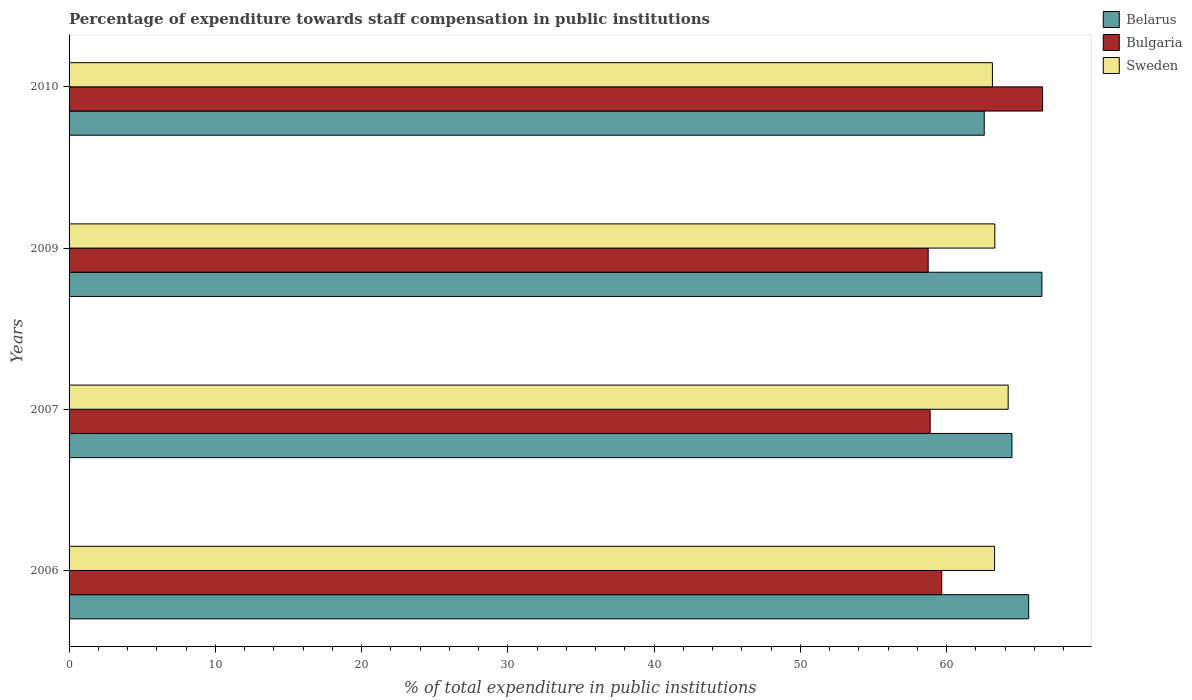How many groups of bars are there?
Your answer should be very brief. 4. Are the number of bars per tick equal to the number of legend labels?
Your answer should be very brief. Yes. Are the number of bars on each tick of the Y-axis equal?
Offer a terse response. Yes. How many bars are there on the 2nd tick from the top?
Give a very brief answer. 3. How many bars are there on the 2nd tick from the bottom?
Provide a short and direct response. 3. What is the label of the 2nd group of bars from the top?
Keep it short and to the point. 2009. What is the percentage of expenditure towards staff compensation in Bulgaria in 2006?
Offer a very short reply. 59.66. Across all years, what is the maximum percentage of expenditure towards staff compensation in Sweden?
Ensure brevity in your answer.  64.2. Across all years, what is the minimum percentage of expenditure towards staff compensation in Sweden?
Ensure brevity in your answer.  63.13. In which year was the percentage of expenditure towards staff compensation in Sweden minimum?
Provide a short and direct response. 2010. What is the total percentage of expenditure towards staff compensation in Sweden in the graph?
Offer a very short reply. 253.89. What is the difference between the percentage of expenditure towards staff compensation in Sweden in 2007 and that in 2009?
Offer a terse response. 0.91. What is the difference between the percentage of expenditure towards staff compensation in Sweden in 2006 and the percentage of expenditure towards staff compensation in Bulgaria in 2007?
Your answer should be very brief. 4.4. What is the average percentage of expenditure towards staff compensation in Bulgaria per year?
Ensure brevity in your answer.  60.95. In the year 2006, what is the difference between the percentage of expenditure towards staff compensation in Bulgaria and percentage of expenditure towards staff compensation in Belarus?
Your answer should be compact. -5.95. In how many years, is the percentage of expenditure towards staff compensation in Belarus greater than 46 %?
Provide a short and direct response. 4. What is the ratio of the percentage of expenditure towards staff compensation in Sweden in 2007 to that in 2010?
Offer a very short reply. 1.02. Is the percentage of expenditure towards staff compensation in Belarus in 2006 less than that in 2009?
Offer a terse response. Yes. Is the difference between the percentage of expenditure towards staff compensation in Bulgaria in 2006 and 2007 greater than the difference between the percentage of expenditure towards staff compensation in Belarus in 2006 and 2007?
Keep it short and to the point. No. What is the difference between the highest and the second highest percentage of expenditure towards staff compensation in Bulgaria?
Ensure brevity in your answer.  6.9. What is the difference between the highest and the lowest percentage of expenditure towards staff compensation in Bulgaria?
Give a very brief answer. 7.82. Is the sum of the percentage of expenditure towards staff compensation in Belarus in 2007 and 2009 greater than the maximum percentage of expenditure towards staff compensation in Bulgaria across all years?
Provide a succinct answer. Yes. What does the 3rd bar from the top in 2006 represents?
Your answer should be very brief. Belarus. What does the 1st bar from the bottom in 2006 represents?
Your answer should be very brief. Belarus. How many bars are there?
Give a very brief answer. 12. Are all the bars in the graph horizontal?
Provide a short and direct response. Yes. What is the difference between two consecutive major ticks on the X-axis?
Keep it short and to the point. 10. Does the graph contain grids?
Ensure brevity in your answer.  No. Where does the legend appear in the graph?
Keep it short and to the point. Top right. How are the legend labels stacked?
Provide a short and direct response. Vertical. What is the title of the graph?
Offer a very short reply. Percentage of expenditure towards staff compensation in public institutions. What is the label or title of the X-axis?
Make the answer very short. % of total expenditure in public institutions. What is the label or title of the Y-axis?
Keep it short and to the point. Years. What is the % of total expenditure in public institutions in Belarus in 2006?
Make the answer very short. 65.6. What is the % of total expenditure in public institutions in Bulgaria in 2006?
Offer a terse response. 59.66. What is the % of total expenditure in public institutions of Sweden in 2006?
Offer a very short reply. 63.27. What is the % of total expenditure in public institutions of Belarus in 2007?
Your answer should be compact. 64.46. What is the % of total expenditure in public institutions in Bulgaria in 2007?
Your answer should be very brief. 58.87. What is the % of total expenditure in public institutions in Sweden in 2007?
Your answer should be compact. 64.2. What is the % of total expenditure in public institutions in Belarus in 2009?
Give a very brief answer. 66.51. What is the % of total expenditure in public institutions in Bulgaria in 2009?
Your answer should be very brief. 58.73. What is the % of total expenditure in public institutions in Sweden in 2009?
Provide a succinct answer. 63.29. What is the % of total expenditure in public institutions of Belarus in 2010?
Your response must be concise. 62.57. What is the % of total expenditure in public institutions in Bulgaria in 2010?
Your response must be concise. 66.56. What is the % of total expenditure in public institutions in Sweden in 2010?
Ensure brevity in your answer.  63.13. Across all years, what is the maximum % of total expenditure in public institutions in Belarus?
Provide a succinct answer. 66.51. Across all years, what is the maximum % of total expenditure in public institutions of Bulgaria?
Provide a succinct answer. 66.56. Across all years, what is the maximum % of total expenditure in public institutions of Sweden?
Keep it short and to the point. 64.2. Across all years, what is the minimum % of total expenditure in public institutions of Belarus?
Offer a very short reply. 62.57. Across all years, what is the minimum % of total expenditure in public institutions in Bulgaria?
Your answer should be very brief. 58.73. Across all years, what is the minimum % of total expenditure in public institutions of Sweden?
Provide a succinct answer. 63.13. What is the total % of total expenditure in public institutions of Belarus in the graph?
Your response must be concise. 259.15. What is the total % of total expenditure in public institutions of Bulgaria in the graph?
Make the answer very short. 243.82. What is the total % of total expenditure in public institutions in Sweden in the graph?
Ensure brevity in your answer.  253.89. What is the difference between the % of total expenditure in public institutions in Belarus in 2006 and that in 2007?
Your response must be concise. 1.14. What is the difference between the % of total expenditure in public institutions in Bulgaria in 2006 and that in 2007?
Offer a terse response. 0.79. What is the difference between the % of total expenditure in public institutions in Sweden in 2006 and that in 2007?
Make the answer very short. -0.93. What is the difference between the % of total expenditure in public institutions in Belarus in 2006 and that in 2009?
Ensure brevity in your answer.  -0.91. What is the difference between the % of total expenditure in public institutions in Bulgaria in 2006 and that in 2009?
Offer a very short reply. 0.93. What is the difference between the % of total expenditure in public institutions of Sweden in 2006 and that in 2009?
Make the answer very short. -0.02. What is the difference between the % of total expenditure in public institutions in Belarus in 2006 and that in 2010?
Make the answer very short. 3.04. What is the difference between the % of total expenditure in public institutions of Bulgaria in 2006 and that in 2010?
Provide a short and direct response. -6.9. What is the difference between the % of total expenditure in public institutions of Sweden in 2006 and that in 2010?
Keep it short and to the point. 0.15. What is the difference between the % of total expenditure in public institutions in Belarus in 2007 and that in 2009?
Give a very brief answer. -2.05. What is the difference between the % of total expenditure in public institutions of Bulgaria in 2007 and that in 2009?
Provide a succinct answer. 0.14. What is the difference between the % of total expenditure in public institutions in Sweden in 2007 and that in 2009?
Offer a terse response. 0.91. What is the difference between the % of total expenditure in public institutions of Belarus in 2007 and that in 2010?
Provide a short and direct response. 1.89. What is the difference between the % of total expenditure in public institutions of Bulgaria in 2007 and that in 2010?
Your answer should be compact. -7.69. What is the difference between the % of total expenditure in public institutions in Sweden in 2007 and that in 2010?
Your answer should be compact. 1.08. What is the difference between the % of total expenditure in public institutions in Belarus in 2009 and that in 2010?
Provide a succinct answer. 3.94. What is the difference between the % of total expenditure in public institutions of Bulgaria in 2009 and that in 2010?
Your response must be concise. -7.82. What is the difference between the % of total expenditure in public institutions of Sweden in 2009 and that in 2010?
Offer a terse response. 0.17. What is the difference between the % of total expenditure in public institutions of Belarus in 2006 and the % of total expenditure in public institutions of Bulgaria in 2007?
Provide a succinct answer. 6.73. What is the difference between the % of total expenditure in public institutions in Belarus in 2006 and the % of total expenditure in public institutions in Sweden in 2007?
Provide a short and direct response. 1.4. What is the difference between the % of total expenditure in public institutions in Bulgaria in 2006 and the % of total expenditure in public institutions in Sweden in 2007?
Make the answer very short. -4.54. What is the difference between the % of total expenditure in public institutions in Belarus in 2006 and the % of total expenditure in public institutions in Bulgaria in 2009?
Your response must be concise. 6.87. What is the difference between the % of total expenditure in public institutions in Belarus in 2006 and the % of total expenditure in public institutions in Sweden in 2009?
Offer a very short reply. 2.31. What is the difference between the % of total expenditure in public institutions of Bulgaria in 2006 and the % of total expenditure in public institutions of Sweden in 2009?
Keep it short and to the point. -3.63. What is the difference between the % of total expenditure in public institutions of Belarus in 2006 and the % of total expenditure in public institutions of Bulgaria in 2010?
Your response must be concise. -0.95. What is the difference between the % of total expenditure in public institutions in Belarus in 2006 and the % of total expenditure in public institutions in Sweden in 2010?
Make the answer very short. 2.48. What is the difference between the % of total expenditure in public institutions in Bulgaria in 2006 and the % of total expenditure in public institutions in Sweden in 2010?
Your answer should be compact. -3.47. What is the difference between the % of total expenditure in public institutions in Belarus in 2007 and the % of total expenditure in public institutions in Bulgaria in 2009?
Your answer should be very brief. 5.73. What is the difference between the % of total expenditure in public institutions in Belarus in 2007 and the % of total expenditure in public institutions in Sweden in 2009?
Your answer should be compact. 1.17. What is the difference between the % of total expenditure in public institutions in Bulgaria in 2007 and the % of total expenditure in public institutions in Sweden in 2009?
Offer a very short reply. -4.42. What is the difference between the % of total expenditure in public institutions of Belarus in 2007 and the % of total expenditure in public institutions of Bulgaria in 2010?
Give a very brief answer. -2.09. What is the difference between the % of total expenditure in public institutions in Belarus in 2007 and the % of total expenditure in public institutions in Sweden in 2010?
Offer a very short reply. 1.34. What is the difference between the % of total expenditure in public institutions in Bulgaria in 2007 and the % of total expenditure in public institutions in Sweden in 2010?
Give a very brief answer. -4.26. What is the difference between the % of total expenditure in public institutions in Belarus in 2009 and the % of total expenditure in public institutions in Bulgaria in 2010?
Provide a succinct answer. -0.04. What is the difference between the % of total expenditure in public institutions of Belarus in 2009 and the % of total expenditure in public institutions of Sweden in 2010?
Offer a very short reply. 3.39. What is the difference between the % of total expenditure in public institutions of Bulgaria in 2009 and the % of total expenditure in public institutions of Sweden in 2010?
Offer a very short reply. -4.39. What is the average % of total expenditure in public institutions in Belarus per year?
Your response must be concise. 64.79. What is the average % of total expenditure in public institutions of Bulgaria per year?
Make the answer very short. 60.95. What is the average % of total expenditure in public institutions in Sweden per year?
Your response must be concise. 63.47. In the year 2006, what is the difference between the % of total expenditure in public institutions in Belarus and % of total expenditure in public institutions in Bulgaria?
Provide a short and direct response. 5.95. In the year 2006, what is the difference between the % of total expenditure in public institutions of Belarus and % of total expenditure in public institutions of Sweden?
Your answer should be very brief. 2.33. In the year 2006, what is the difference between the % of total expenditure in public institutions of Bulgaria and % of total expenditure in public institutions of Sweden?
Keep it short and to the point. -3.61. In the year 2007, what is the difference between the % of total expenditure in public institutions in Belarus and % of total expenditure in public institutions in Bulgaria?
Provide a short and direct response. 5.59. In the year 2007, what is the difference between the % of total expenditure in public institutions of Belarus and % of total expenditure in public institutions of Sweden?
Provide a short and direct response. 0.26. In the year 2007, what is the difference between the % of total expenditure in public institutions in Bulgaria and % of total expenditure in public institutions in Sweden?
Offer a very short reply. -5.33. In the year 2009, what is the difference between the % of total expenditure in public institutions in Belarus and % of total expenditure in public institutions in Bulgaria?
Keep it short and to the point. 7.78. In the year 2009, what is the difference between the % of total expenditure in public institutions in Belarus and % of total expenditure in public institutions in Sweden?
Make the answer very short. 3.22. In the year 2009, what is the difference between the % of total expenditure in public institutions of Bulgaria and % of total expenditure in public institutions of Sweden?
Offer a very short reply. -4.56. In the year 2010, what is the difference between the % of total expenditure in public institutions of Belarus and % of total expenditure in public institutions of Bulgaria?
Keep it short and to the point. -3.99. In the year 2010, what is the difference between the % of total expenditure in public institutions in Belarus and % of total expenditure in public institutions in Sweden?
Provide a succinct answer. -0.56. In the year 2010, what is the difference between the % of total expenditure in public institutions of Bulgaria and % of total expenditure in public institutions of Sweden?
Make the answer very short. 3.43. What is the ratio of the % of total expenditure in public institutions of Belarus in 2006 to that in 2007?
Offer a very short reply. 1.02. What is the ratio of the % of total expenditure in public institutions of Bulgaria in 2006 to that in 2007?
Give a very brief answer. 1.01. What is the ratio of the % of total expenditure in public institutions of Sweden in 2006 to that in 2007?
Provide a succinct answer. 0.99. What is the ratio of the % of total expenditure in public institutions in Belarus in 2006 to that in 2009?
Your answer should be compact. 0.99. What is the ratio of the % of total expenditure in public institutions in Bulgaria in 2006 to that in 2009?
Ensure brevity in your answer.  1.02. What is the ratio of the % of total expenditure in public institutions in Sweden in 2006 to that in 2009?
Your answer should be compact. 1. What is the ratio of the % of total expenditure in public institutions in Belarus in 2006 to that in 2010?
Give a very brief answer. 1.05. What is the ratio of the % of total expenditure in public institutions of Bulgaria in 2006 to that in 2010?
Give a very brief answer. 0.9. What is the ratio of the % of total expenditure in public institutions in Sweden in 2006 to that in 2010?
Your answer should be compact. 1. What is the ratio of the % of total expenditure in public institutions in Belarus in 2007 to that in 2009?
Your response must be concise. 0.97. What is the ratio of the % of total expenditure in public institutions of Bulgaria in 2007 to that in 2009?
Offer a terse response. 1. What is the ratio of the % of total expenditure in public institutions of Sweden in 2007 to that in 2009?
Provide a succinct answer. 1.01. What is the ratio of the % of total expenditure in public institutions of Belarus in 2007 to that in 2010?
Provide a short and direct response. 1.03. What is the ratio of the % of total expenditure in public institutions in Bulgaria in 2007 to that in 2010?
Ensure brevity in your answer.  0.88. What is the ratio of the % of total expenditure in public institutions in Sweden in 2007 to that in 2010?
Ensure brevity in your answer.  1.02. What is the ratio of the % of total expenditure in public institutions in Belarus in 2009 to that in 2010?
Your response must be concise. 1.06. What is the ratio of the % of total expenditure in public institutions in Bulgaria in 2009 to that in 2010?
Offer a very short reply. 0.88. What is the ratio of the % of total expenditure in public institutions in Sweden in 2009 to that in 2010?
Give a very brief answer. 1. What is the difference between the highest and the second highest % of total expenditure in public institutions in Belarus?
Make the answer very short. 0.91. What is the difference between the highest and the second highest % of total expenditure in public institutions of Bulgaria?
Your response must be concise. 6.9. What is the difference between the highest and the second highest % of total expenditure in public institutions in Sweden?
Offer a terse response. 0.91. What is the difference between the highest and the lowest % of total expenditure in public institutions of Belarus?
Your response must be concise. 3.94. What is the difference between the highest and the lowest % of total expenditure in public institutions of Bulgaria?
Your answer should be compact. 7.82. What is the difference between the highest and the lowest % of total expenditure in public institutions of Sweden?
Make the answer very short. 1.08. 